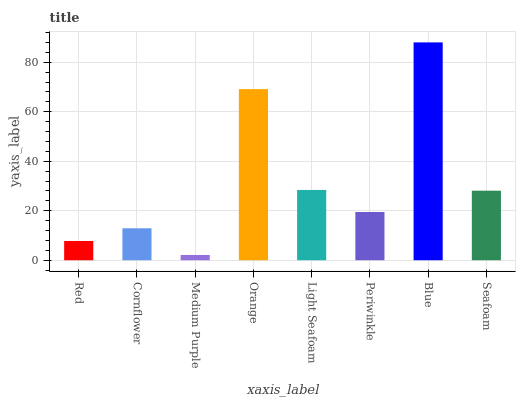Is Medium Purple the minimum?
Answer yes or no. Yes. Is Blue the maximum?
Answer yes or no. Yes. Is Cornflower the minimum?
Answer yes or no. No. Is Cornflower the maximum?
Answer yes or no. No. Is Cornflower greater than Red?
Answer yes or no. Yes. Is Red less than Cornflower?
Answer yes or no. Yes. Is Red greater than Cornflower?
Answer yes or no. No. Is Cornflower less than Red?
Answer yes or no. No. Is Seafoam the high median?
Answer yes or no. Yes. Is Periwinkle the low median?
Answer yes or no. Yes. Is Blue the high median?
Answer yes or no. No. Is Seafoam the low median?
Answer yes or no. No. 